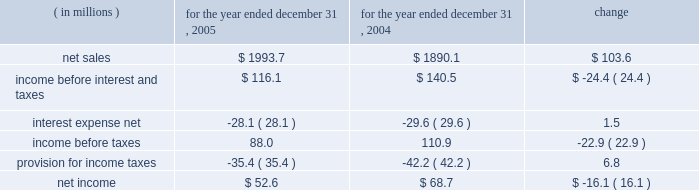Item 7 .
Management 2019s discussion and analysis of financial condition and results of operations the following discussion of historical results of operations and financial condition should be read in conjunction with the audited financial statements and the notes thereto which appear elsewhere in this report .
Overview on april 12 , 1999 , pca acquired the containerboard and corrugated products business of pactiv corporation ( the 201cgroup 201d ) , formerly known as tenneco packaging inc. , a wholly owned subsidiary of tenneco , inc .
The group operated prior to april 12 , 1999 as a division of pactiv , and not as a separate , stand-alone entity .
From its formation in january 1999 and through the closing of the acquisition on april 12 , 1999 , pca did not have any significant operations .
The april 12 , 1999 acquisition was accounted for using historical values for the contributed assets .
Purchase accounting was not applied because , under the applicable accounting guidance , a change of control was deemed not to have occurred as a result of the participating veto rights held by pactiv after the closing of the transactions under the terms of the stockholders agreement entered into in connection with the transactions .
Results of operations year ended december 31 , 2005 compared to year ended december 31 , 2004 the historical results of operations of pca for the years ended december , 31 2005 and 2004 are set forth the below : for the year ended december 31 , ( in millions ) 2005 2004 change .
Net sales net sales increased by $ 103.6 million , or 5.5% ( 5.5 % ) , for the year ended december 31 , 2005 from the year ended december 31 , 2004 .
Net sales increased primarily due to increased sales prices and volumes of corrugated products compared to 2004 .
Total corrugated products volume sold increased 4.2% ( 4.2 % ) to 31.2 billion square feet in 2005 compared to 29.9 billion square feet in 2004 .
On a comparable shipment-per-workday basis , corrugated products sales volume increased 4.6% ( 4.6 % ) in 2005 from 2004 .
Excluding pca 2019s acquisition of midland container in april 2005 , corrugated products volume was 3.0% ( 3.0 % ) higher in 2005 than 2004 and up 3.4% ( 3.4 % ) compared to 2004 on a shipment-per-workday basis .
Shipments-per-workday is calculated by dividing our total corrugated products volume during the year by the number of workdays within the year .
The larger percentage increase was due to the fact that 2005 had one less workday ( 250 days ) , those days not falling on a weekend or holiday , than 2004 ( 251 days ) .
Containerboard sales volume to external domestic and export customers decreased 12.2% ( 12.2 % ) to 417000 tons for the year ended december 31 , 2005 from 475000 tons in 2004. .
What was the effective tax rate for pca in 2004? 
Computations: (42.2 / 110.9)
Answer: 0.38052. 